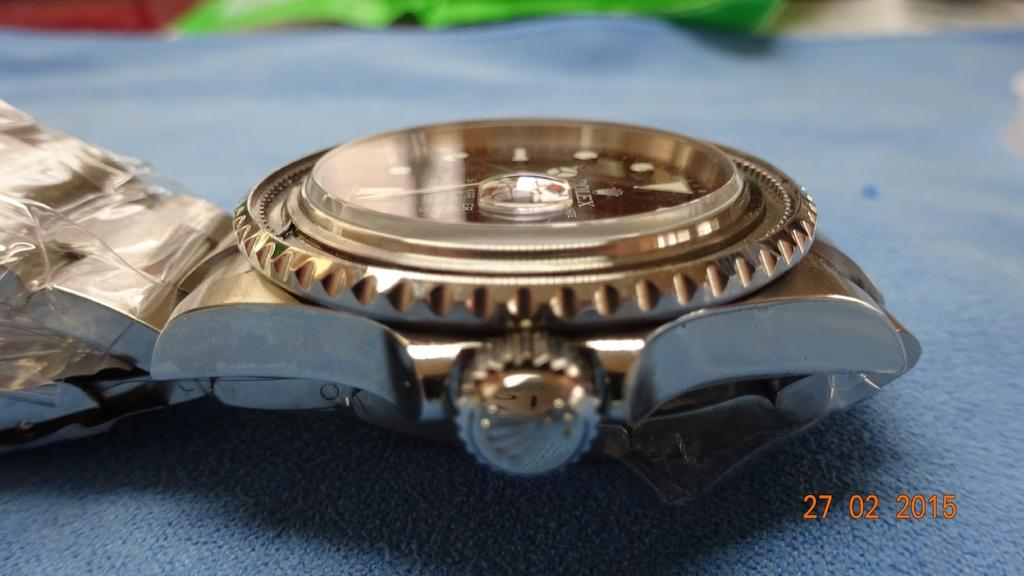Provide a one-sentence caption for the provided image. At the center of a watch face is the name Rolex. 